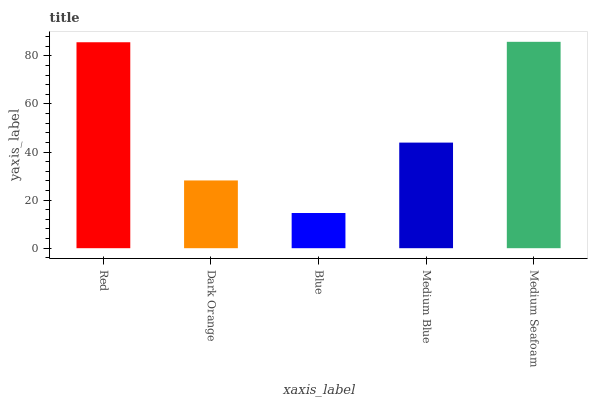Is Blue the minimum?
Answer yes or no. Yes. Is Medium Seafoam the maximum?
Answer yes or no. Yes. Is Dark Orange the minimum?
Answer yes or no. No. Is Dark Orange the maximum?
Answer yes or no. No. Is Red greater than Dark Orange?
Answer yes or no. Yes. Is Dark Orange less than Red?
Answer yes or no. Yes. Is Dark Orange greater than Red?
Answer yes or no. No. Is Red less than Dark Orange?
Answer yes or no. No. Is Medium Blue the high median?
Answer yes or no. Yes. Is Medium Blue the low median?
Answer yes or no. Yes. Is Blue the high median?
Answer yes or no. No. Is Blue the low median?
Answer yes or no. No. 